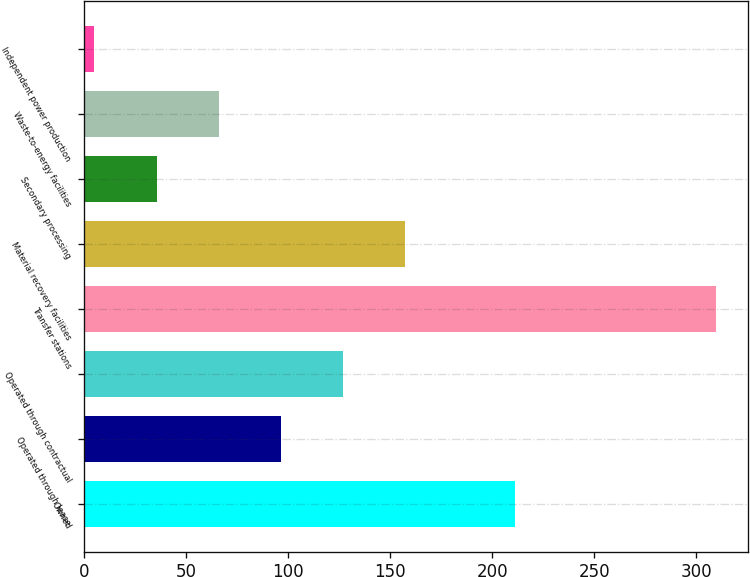<chart> <loc_0><loc_0><loc_500><loc_500><bar_chart><fcel>Owned<fcel>Operated through lease<fcel>Operated through contractual<fcel>Transfer stations<fcel>Material recovery facilities<fcel>Secondary processing<fcel>Waste-to-energy facilities<fcel>Independent power production<nl><fcel>211<fcel>96.5<fcel>127<fcel>310<fcel>157.5<fcel>35.5<fcel>66<fcel>5<nl></chart> 